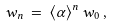<formula> <loc_0><loc_0><loc_500><loc_500>w _ { n } \, = \, \langle \alpha \rangle ^ { n } \, w _ { 0 } \, ,</formula> 